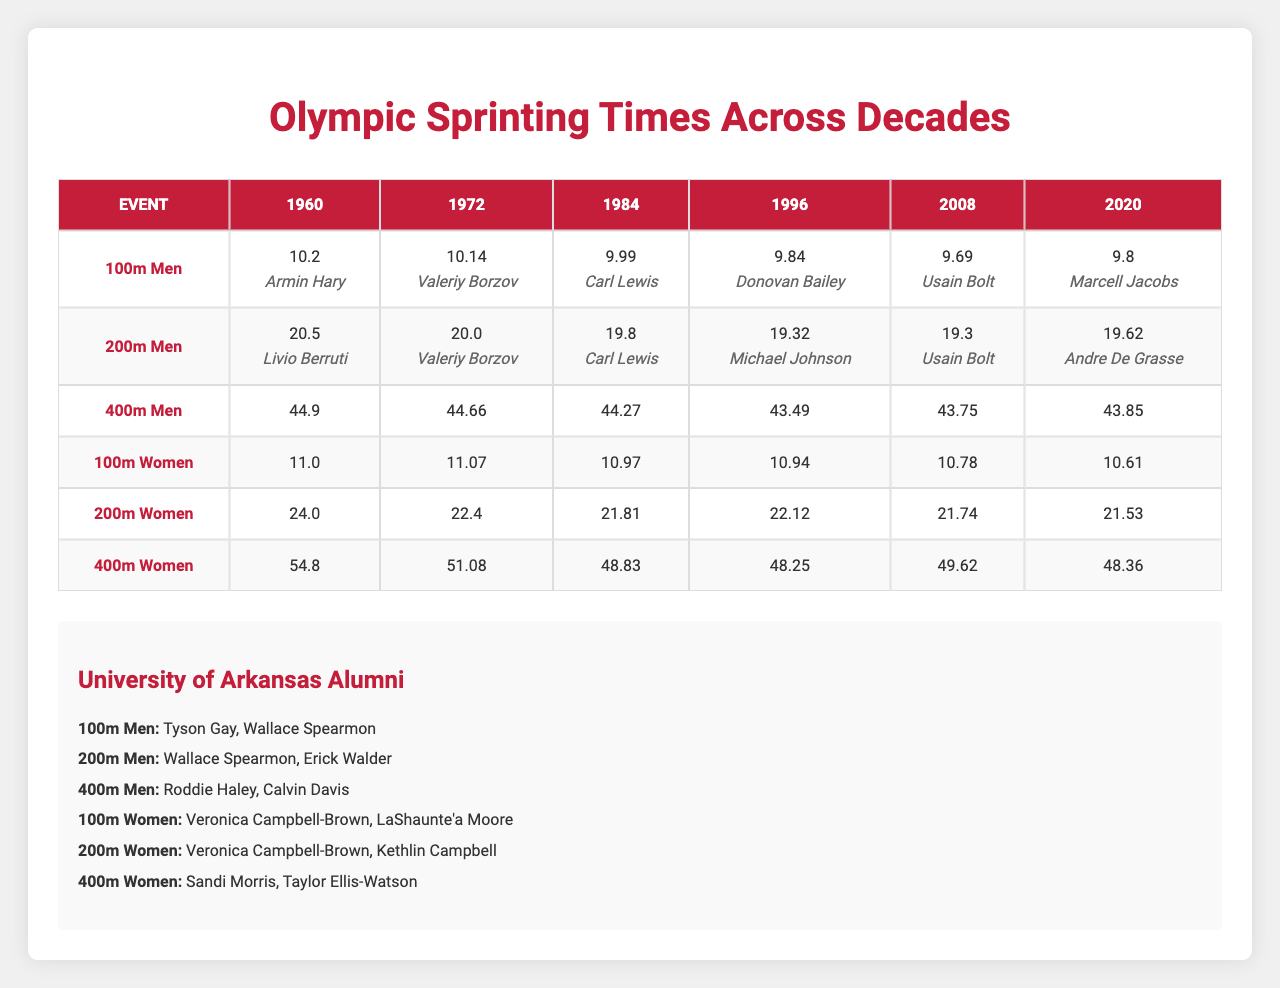What was the winning time for the 100m Men event in 1984? The table lists the winning time for the 100m Men event as 9.99 seconds for the year 1984.
Answer: 9.99 seconds Which athlete won the 200m Men event in 2008? According to the table, Usain Bolt won the 200m Men event in 2008.
Answer: Usain Bolt What was the difference in winning times for the 400m Men event between 1984 and 2008? The winning time for the 400m Men event in 1984 was 44.27 seconds, while in 2008 it was 43.75 seconds. The difference is calculated as 44.27 - 43.75 = 0.52 seconds.
Answer: 0.52 seconds Which event had the fastest winning time in 2020? From the table, the fastest winning times in 2020 were for the 100m Men (9.80 seconds) and the 100m Women (10.61 seconds). The fastest between these is 9.80 seconds for the 100m Men.
Answer: 9.80 seconds What is the average winning time for the 200m Women across all decades? The winning times for the 200m Women are: 24.0 (1960), 22.40 (1972), 21.81 (1984), 22.12 (1996), 21.74 (2008), and 21.53 (2020). The total sum is 24.0 + 22.40 + 21.81 + 22.12 + 21.74 + 21.53 = 133.60 seconds. There are 6 values, so the average is 133.60 / 6 = 22.27 seconds.
Answer: 22.27 seconds Did any University of Arkansas alumni win the 400m Women event? The table indicates that there are notable athletes, but it does not mention any specific winners from the University of Arkansas for the 400m Women event.
Answer: No What was the trend in winning times for the 100m Women event from 1960 to 2020? The winning times in the 100m Women event decreased from 11.0 seconds in 1960 to 10.61 seconds in 2020, showing a trend of improvement over the decades.
Answer: Decreased Which notable athlete won the 100m Men event in 2008, and how does their winning time compare to the 100m Men winning time in 2020? Usain Bolt won the 100m Men event in 2008 with a winning time of 9.69 seconds. The winning time in 2020 was 9.80 seconds. The comparison shows that Usain Bolt's time was 0.11 seconds faster than the time in 2020.
Answer: 0.11 seconds faster What is the highest winning time for the 400m Men event recorded in the table? The highest winning time for the 400m Men event recorded was 44.9 seconds in 1960.
Answer: 44.9 seconds What has been the average winning time for the 400m Women from 1960 to 2020? The winning times for the 400m Women are 54.8 (1960), 51.08 (1972), 48.83 (1984), 48.25 (1996), 49.62 (2008), and 48.36 (2020). Their total is 54.8 + 51.08 + 48.83 + 48.25 + 49.62 + 48.36 = 302.94 seconds. The average is 302.94 / 6 = 50.49 seconds.
Answer: 50.49 seconds 